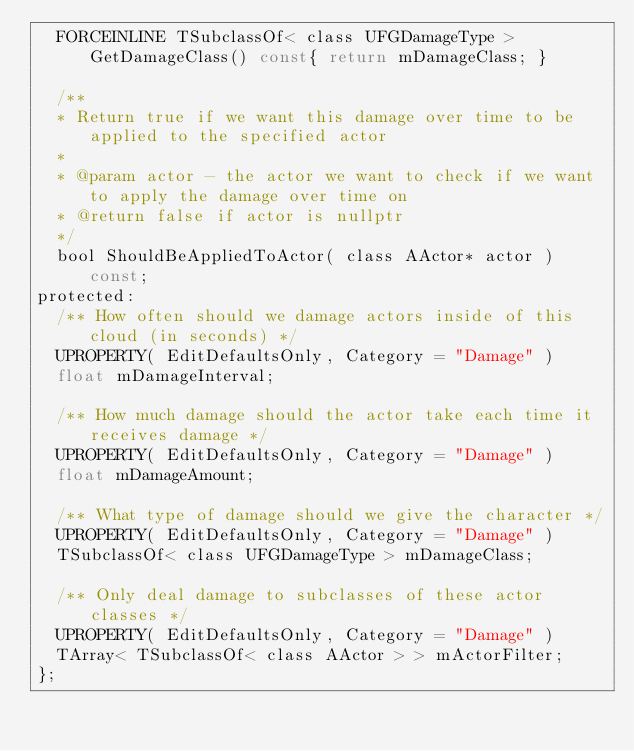Convert code to text. <code><loc_0><loc_0><loc_500><loc_500><_C_>	FORCEINLINE TSubclassOf< class UFGDamageType > GetDamageClass() const{ return mDamageClass; }

	/**
	* Return true if we want this damage over time to be applied to the specified actor
	*
	* @param actor - the actor we want to check if we want to apply the damage over time on
	* @return false if actor is nullptr
	*/
	bool ShouldBeAppliedToActor( class AActor* actor ) const;
protected:
	/** How often should we damage actors inside of this cloud (in seconds) */
	UPROPERTY( EditDefaultsOnly, Category = "Damage" )
	float mDamageInterval;

	/** How much damage should the actor take each time it receives damage */
	UPROPERTY( EditDefaultsOnly, Category = "Damage" )
	float mDamageAmount;

	/** What type of damage should we give the character */
	UPROPERTY( EditDefaultsOnly, Category = "Damage" )
	TSubclassOf< class UFGDamageType > mDamageClass;

	/** Only deal damage to subclasses of these actor classes */
	UPROPERTY( EditDefaultsOnly, Category = "Damage" )
	TArray< TSubclassOf< class AActor > > mActorFilter;
};
</code> 